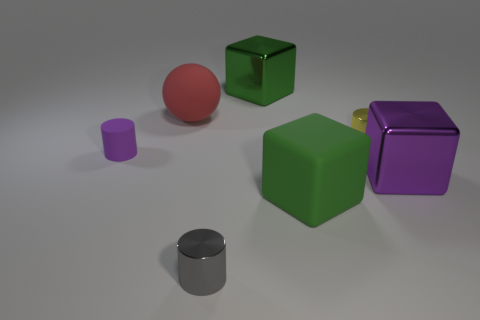How many green blocks must be subtracted to get 1 green blocks? 1 Add 3 matte cylinders. How many objects exist? 10 Subtract all spheres. How many objects are left? 6 Subtract 0 blue spheres. How many objects are left? 7 Subtract all purple objects. Subtract all tiny shiny cylinders. How many objects are left? 3 Add 1 tiny objects. How many tiny objects are left? 4 Add 1 large brown matte spheres. How many large brown matte spheres exist? 1 